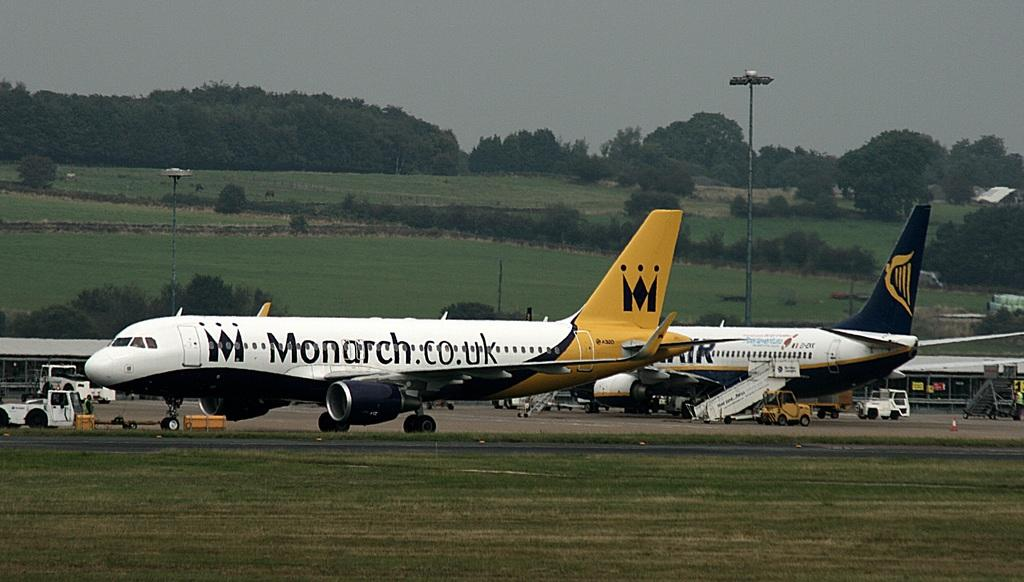<image>
Present a compact description of the photo's key features. A plane with Monarch.co.uk written on it is sitting on the runway next to another plane. 